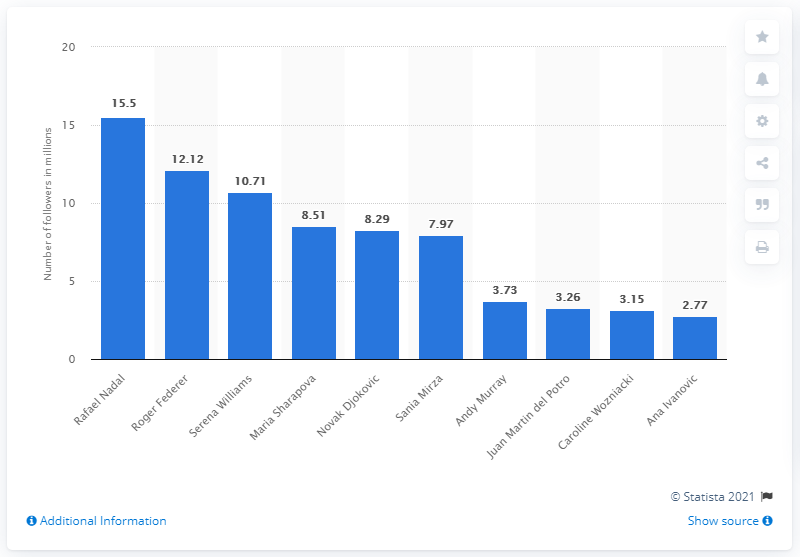List a handful of essential elements in this visual. Rafael Nadal was ranked first on Twitter in June 2018 among Spanish tennis players. 